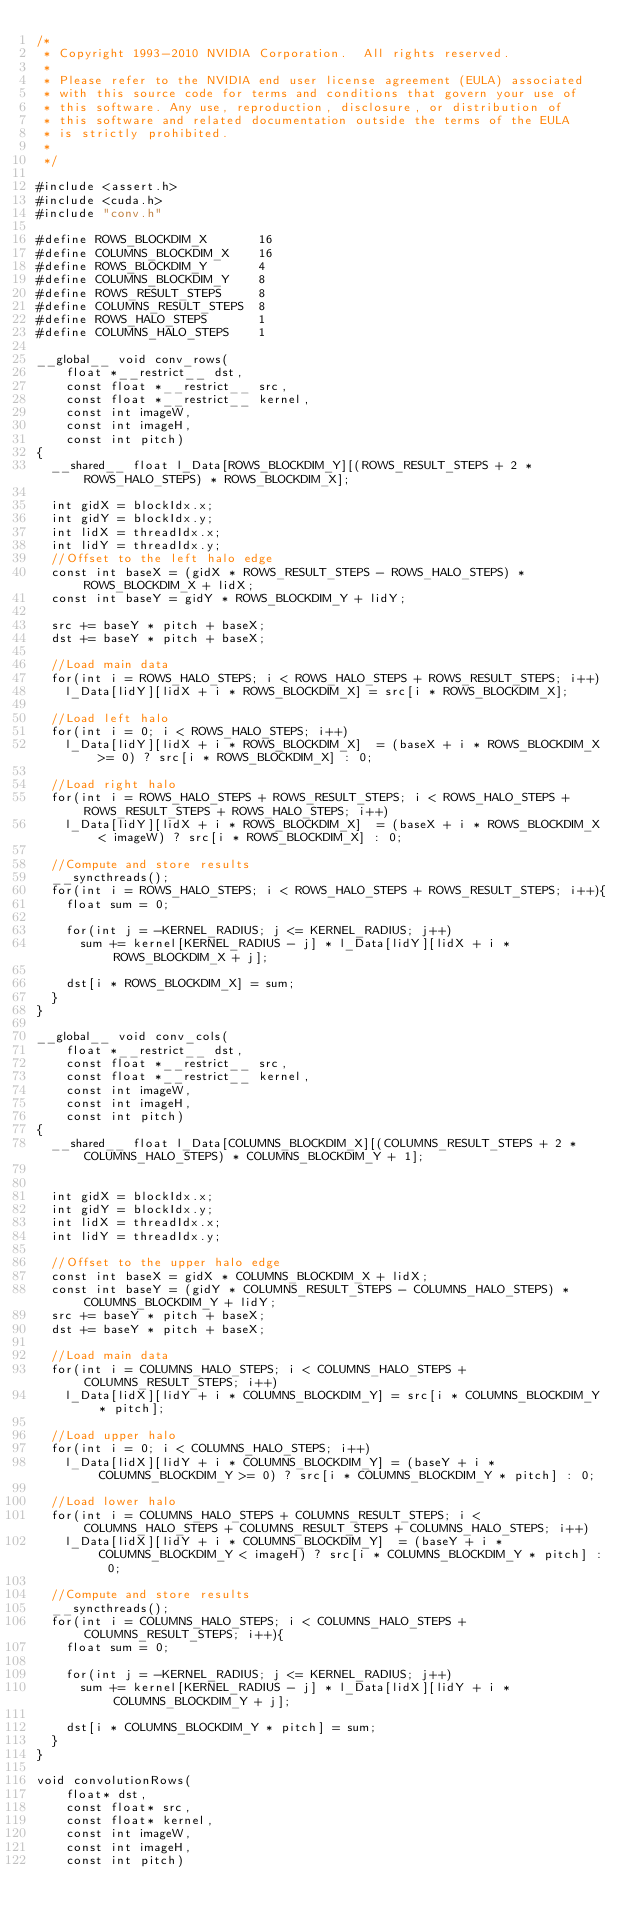<code> <loc_0><loc_0><loc_500><loc_500><_Cuda_>/*
 * Copyright 1993-2010 NVIDIA Corporation.  All rights reserved.
 *
 * Please refer to the NVIDIA end user license agreement (EULA) associated
 * with this source code for terms and conditions that govern your use of
 * this software. Any use, reproduction, disclosure, or distribution of
 * this software and related documentation outside the terms of the EULA
 * is strictly prohibited.
 *
 */

#include <assert.h>
#include <cuda.h>
#include "conv.h"

#define ROWS_BLOCKDIM_X       16
#define COLUMNS_BLOCKDIM_X    16
#define ROWS_BLOCKDIM_Y       4
#define COLUMNS_BLOCKDIM_Y    8
#define ROWS_RESULT_STEPS     8
#define COLUMNS_RESULT_STEPS  8
#define ROWS_HALO_STEPS       1
#define COLUMNS_HALO_STEPS    1

__global__ void conv_rows(
    float *__restrict__ dst,
    const float *__restrict__ src,
    const float *__restrict__ kernel,
    const int imageW,
    const int imageH,
    const int pitch)
{
  __shared__ float l_Data[ROWS_BLOCKDIM_Y][(ROWS_RESULT_STEPS + 2 * ROWS_HALO_STEPS) * ROWS_BLOCKDIM_X];

  int gidX = blockIdx.x;
  int gidY = blockIdx.y;
  int lidX = threadIdx.x;
  int lidY = threadIdx.y;
  //Offset to the left halo edge
  const int baseX = (gidX * ROWS_RESULT_STEPS - ROWS_HALO_STEPS) * ROWS_BLOCKDIM_X + lidX;
  const int baseY = gidY * ROWS_BLOCKDIM_Y + lidY;

  src += baseY * pitch + baseX;
  dst += baseY * pitch + baseX;

  //Load main data
  for(int i = ROWS_HALO_STEPS; i < ROWS_HALO_STEPS + ROWS_RESULT_STEPS; i++)
    l_Data[lidY][lidX + i * ROWS_BLOCKDIM_X] = src[i * ROWS_BLOCKDIM_X];

  //Load left halo
  for(int i = 0; i < ROWS_HALO_STEPS; i++)
    l_Data[lidY][lidX + i * ROWS_BLOCKDIM_X]  = (baseX + i * ROWS_BLOCKDIM_X >= 0) ? src[i * ROWS_BLOCKDIM_X] : 0;

  //Load right halo
  for(int i = ROWS_HALO_STEPS + ROWS_RESULT_STEPS; i < ROWS_HALO_STEPS + ROWS_RESULT_STEPS + ROWS_HALO_STEPS; i++)
    l_Data[lidY][lidX + i * ROWS_BLOCKDIM_X]  = (baseX + i * ROWS_BLOCKDIM_X < imageW) ? src[i * ROWS_BLOCKDIM_X] : 0;

  //Compute and store results
  __syncthreads();
  for(int i = ROWS_HALO_STEPS; i < ROWS_HALO_STEPS + ROWS_RESULT_STEPS; i++){
    float sum = 0;

    for(int j = -KERNEL_RADIUS; j <= KERNEL_RADIUS; j++)
      sum += kernel[KERNEL_RADIUS - j] * l_Data[lidY][lidX + i * ROWS_BLOCKDIM_X + j];

    dst[i * ROWS_BLOCKDIM_X] = sum;
  }
}

__global__ void conv_cols(
    float *__restrict__ dst,
    const float *__restrict__ src,
    const float *__restrict__ kernel,
    const int imageW,
    const int imageH,
    const int pitch)
{
  __shared__ float l_Data[COLUMNS_BLOCKDIM_X][(COLUMNS_RESULT_STEPS + 2 * COLUMNS_HALO_STEPS) * COLUMNS_BLOCKDIM_Y + 1];


  int gidX = blockIdx.x;
  int gidY = blockIdx.y;
  int lidX = threadIdx.x;
  int lidY = threadIdx.y;

  //Offset to the upper halo edge
  const int baseX = gidX * COLUMNS_BLOCKDIM_X + lidX;
  const int baseY = (gidY * COLUMNS_RESULT_STEPS - COLUMNS_HALO_STEPS) * COLUMNS_BLOCKDIM_Y + lidY;
  src += baseY * pitch + baseX;
  dst += baseY * pitch + baseX;

  //Load main data
  for(int i = COLUMNS_HALO_STEPS; i < COLUMNS_HALO_STEPS + COLUMNS_RESULT_STEPS; i++)
    l_Data[lidX][lidY + i * COLUMNS_BLOCKDIM_Y] = src[i * COLUMNS_BLOCKDIM_Y * pitch];

  //Load upper halo
  for(int i = 0; i < COLUMNS_HALO_STEPS; i++)
    l_Data[lidX][lidY + i * COLUMNS_BLOCKDIM_Y] = (baseY + i * COLUMNS_BLOCKDIM_Y >= 0) ? src[i * COLUMNS_BLOCKDIM_Y * pitch] : 0;

  //Load lower halo
  for(int i = COLUMNS_HALO_STEPS + COLUMNS_RESULT_STEPS; i < COLUMNS_HALO_STEPS + COLUMNS_RESULT_STEPS + COLUMNS_HALO_STEPS; i++)
    l_Data[lidX][lidY + i * COLUMNS_BLOCKDIM_Y]  = (baseY + i * COLUMNS_BLOCKDIM_Y < imageH) ? src[i * COLUMNS_BLOCKDIM_Y * pitch] : 0;

  //Compute and store results
  __syncthreads();
  for(int i = COLUMNS_HALO_STEPS; i < COLUMNS_HALO_STEPS + COLUMNS_RESULT_STEPS; i++){
    float sum = 0;

    for(int j = -KERNEL_RADIUS; j <= KERNEL_RADIUS; j++)
      sum += kernel[KERNEL_RADIUS - j] * l_Data[lidX][lidY + i * COLUMNS_BLOCKDIM_Y + j];

    dst[i * COLUMNS_BLOCKDIM_Y * pitch] = sum;
  }
}

void convolutionRows(
    float* dst,
    const float* src,
    const float* kernel,
    const int imageW,
    const int imageH,
    const int pitch)</code> 